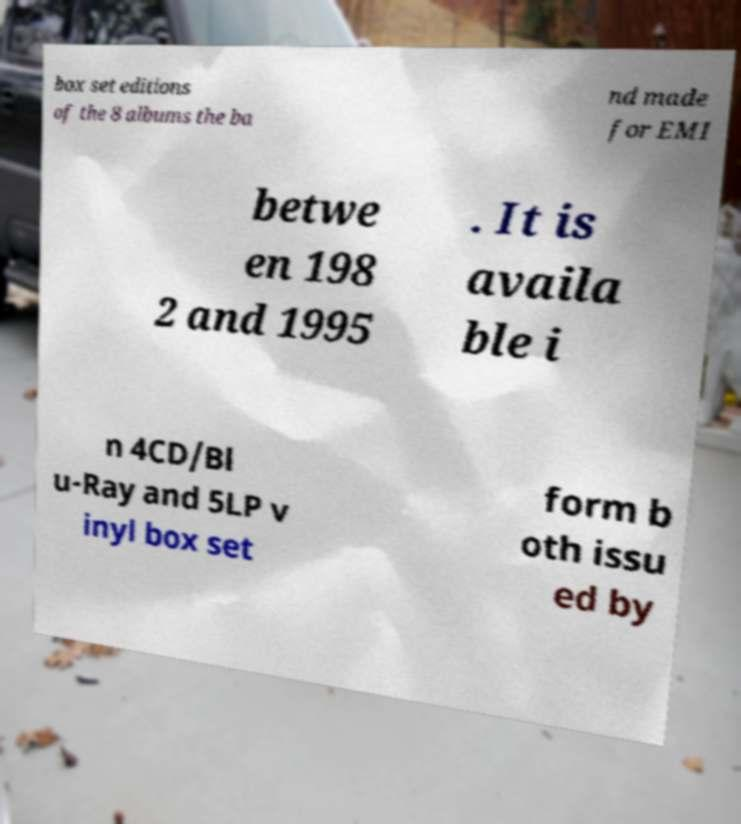For documentation purposes, I need the text within this image transcribed. Could you provide that? box set editions of the 8 albums the ba nd made for EMI betwe en 198 2 and 1995 . It is availa ble i n 4CD/Bl u-Ray and 5LP v inyl box set form b oth issu ed by 